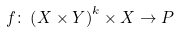<formula> <loc_0><loc_0><loc_500><loc_500>f \colon \left ( X \times Y \right ) ^ { k } \times X \to P</formula> 